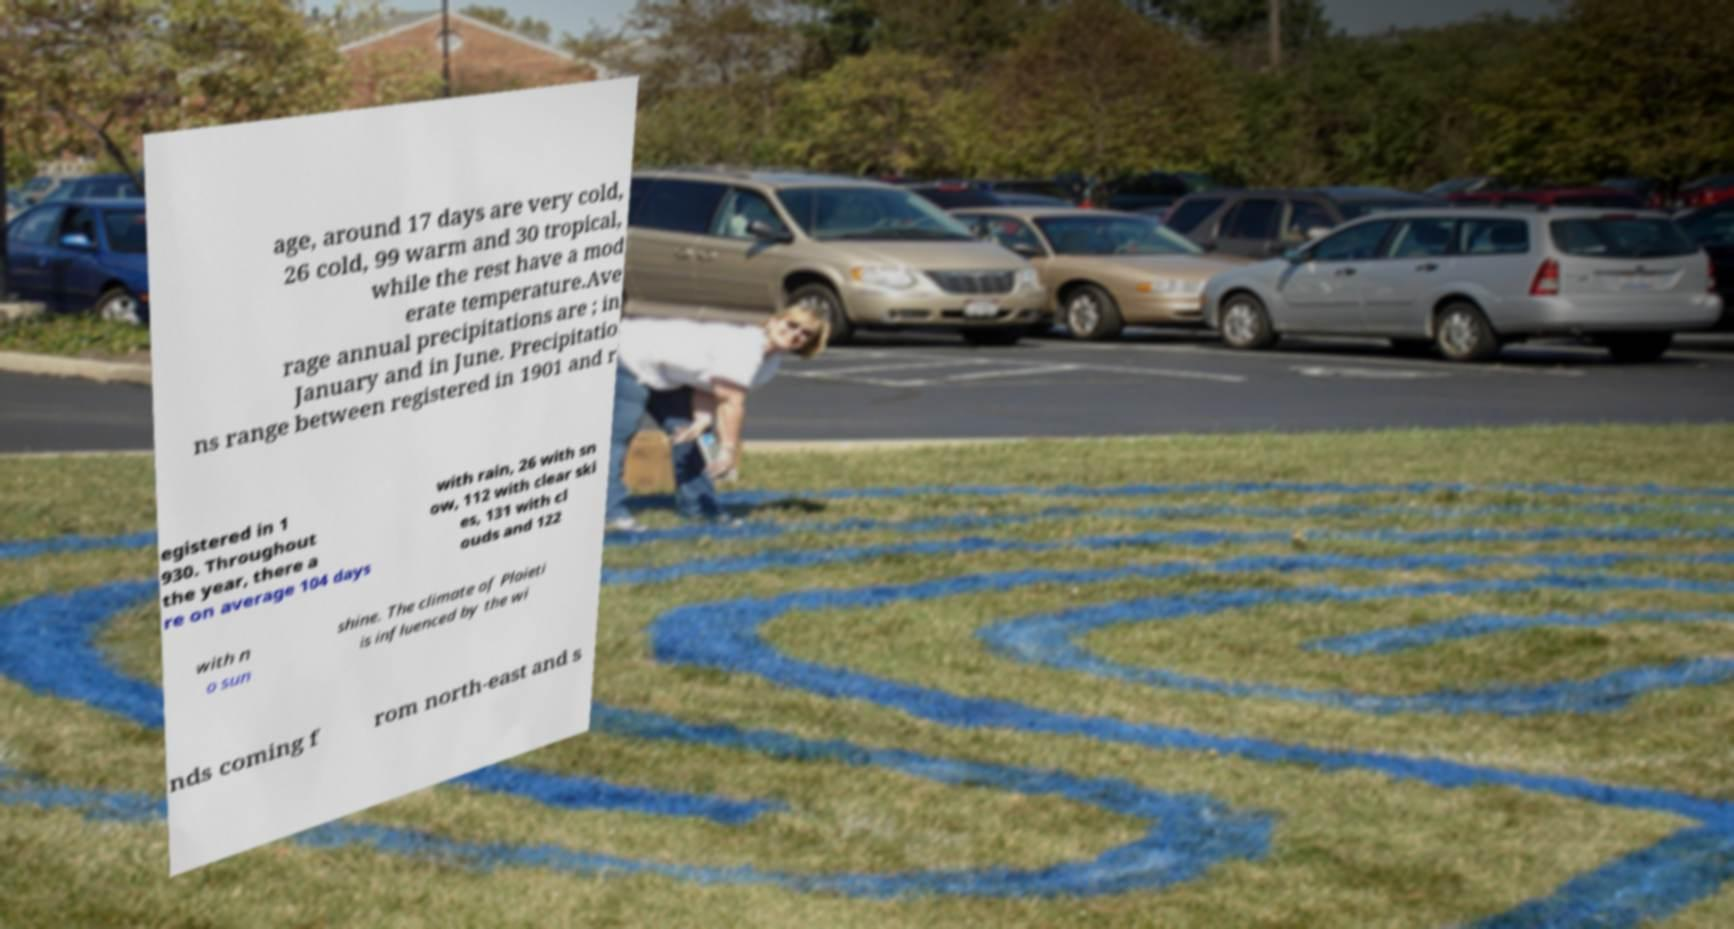Could you assist in decoding the text presented in this image and type it out clearly? age, around 17 days are very cold, 26 cold, 99 warm and 30 tropical, while the rest have a mod erate temperature.Ave rage annual precipitations are ; in January and in June. Precipitatio ns range between registered in 1901 and r egistered in 1 930. Throughout the year, there a re on average 104 days with rain, 26 with sn ow, 112 with clear ski es, 131 with cl ouds and 122 with n o sun shine. The climate of Ploieti is influenced by the wi nds coming f rom north-east and s 